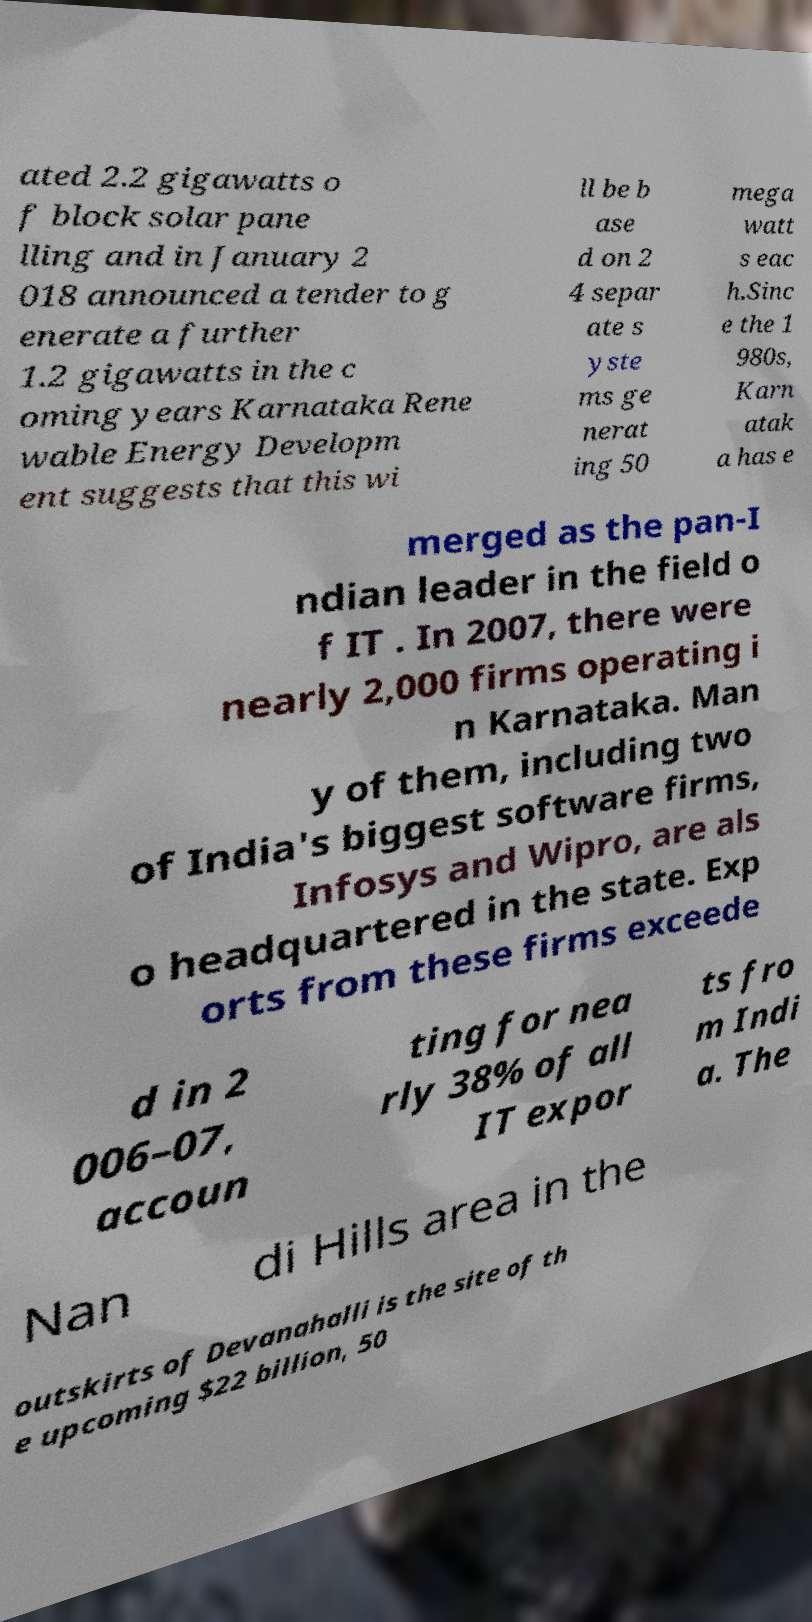Please identify and transcribe the text found in this image. ated 2.2 gigawatts o f block solar pane lling and in January 2 018 announced a tender to g enerate a further 1.2 gigawatts in the c oming years Karnataka Rene wable Energy Developm ent suggests that this wi ll be b ase d on 2 4 separ ate s yste ms ge nerat ing 50 mega watt s eac h.Sinc e the 1 980s, Karn atak a has e merged as the pan-I ndian leader in the field o f IT . In 2007, there were nearly 2,000 firms operating i n Karnataka. Man y of them, including two of India's biggest software firms, Infosys and Wipro, are als o headquartered in the state. Exp orts from these firms exceede d in 2 006–07, accoun ting for nea rly 38% of all IT expor ts fro m Indi a. The Nan di Hills area in the outskirts of Devanahalli is the site of th e upcoming $22 billion, 50 